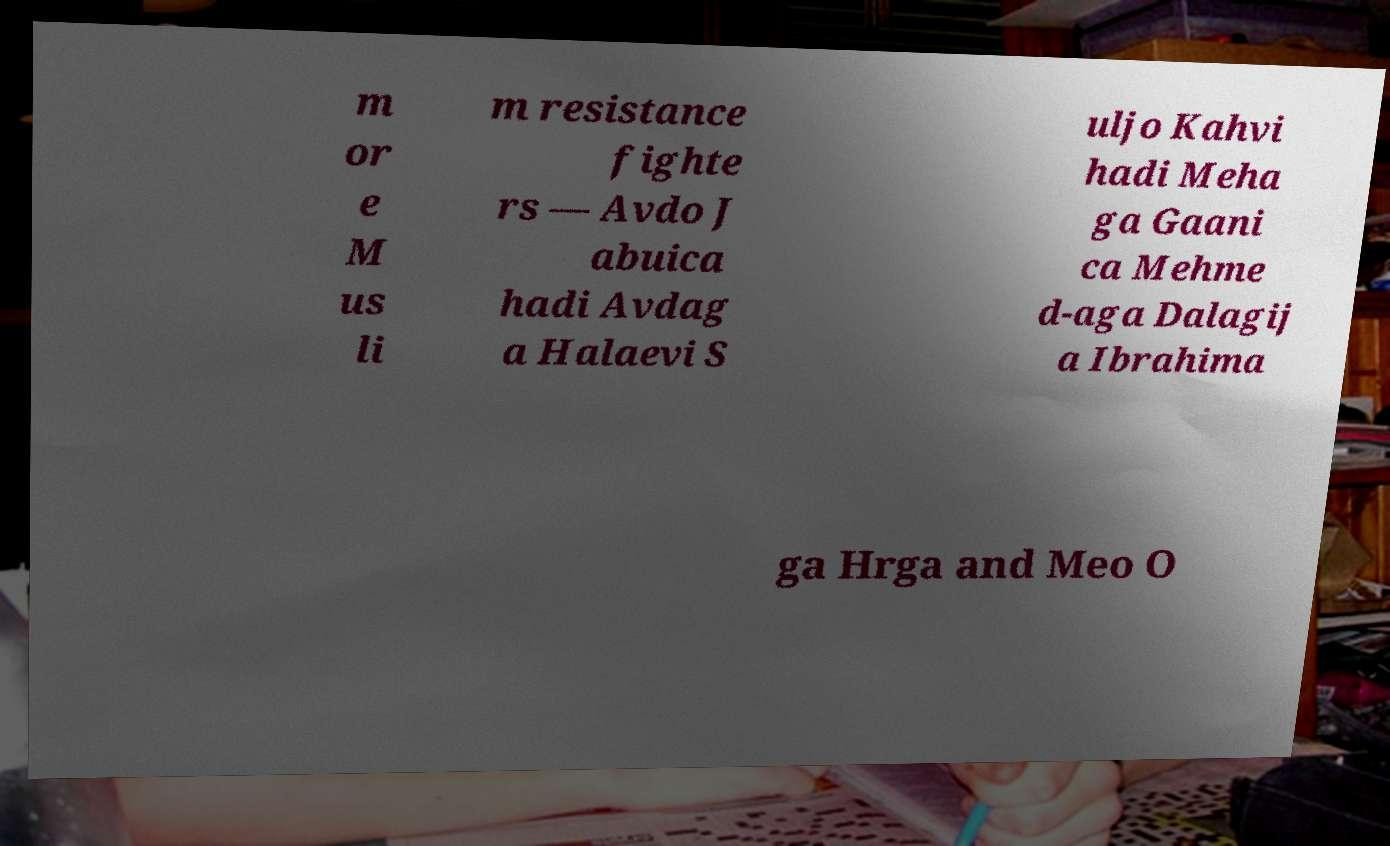Please identify and transcribe the text found in this image. m or e M us li m resistance fighte rs — Avdo J abuica hadi Avdag a Halaevi S uljo Kahvi hadi Meha ga Gaani ca Mehme d-aga Dalagij a Ibrahima ga Hrga and Meo O 